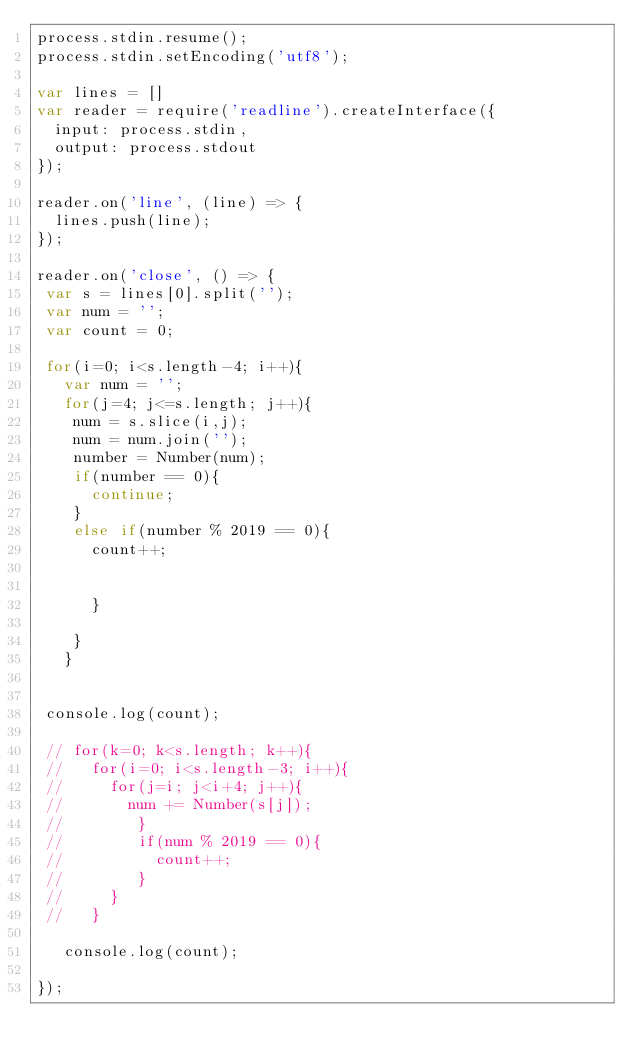Convert code to text. <code><loc_0><loc_0><loc_500><loc_500><_JavaScript_>process.stdin.resume();
process.stdin.setEncoding('utf8');

var lines = []
var reader = require('readline').createInterface({
  input: process.stdin,
  output: process.stdout
});

reader.on('line', (line) => {
  lines.push(line);
});

reader.on('close', () => {
 var s = lines[0].split('');
 var num = '';
 var count = 0;

 for(i=0; i<s.length-4; i++){
   var num = '';
   for(j=4; j<=s.length; j++){
    num = s.slice(i,j);
    num = num.join('');
    number = Number(num);
    if(number == 0){
      continue;
    }
    else if(number % 2019 == 0){
      count++;
  
      
      }
    
    }
   }
   
 
 console.log(count);

 // for(k=0; k<s.length; k++){
 //   for(i=0; i<s.length-3; i++){
 //     for(j=i; j<i+4; j++){
 //       num += Number(s[j]);
 //        }
 //        if(num % 2019 == 0){
 //          count++;
 //        }
 //     }
 //   }

   console.log(count);
 
});</code> 